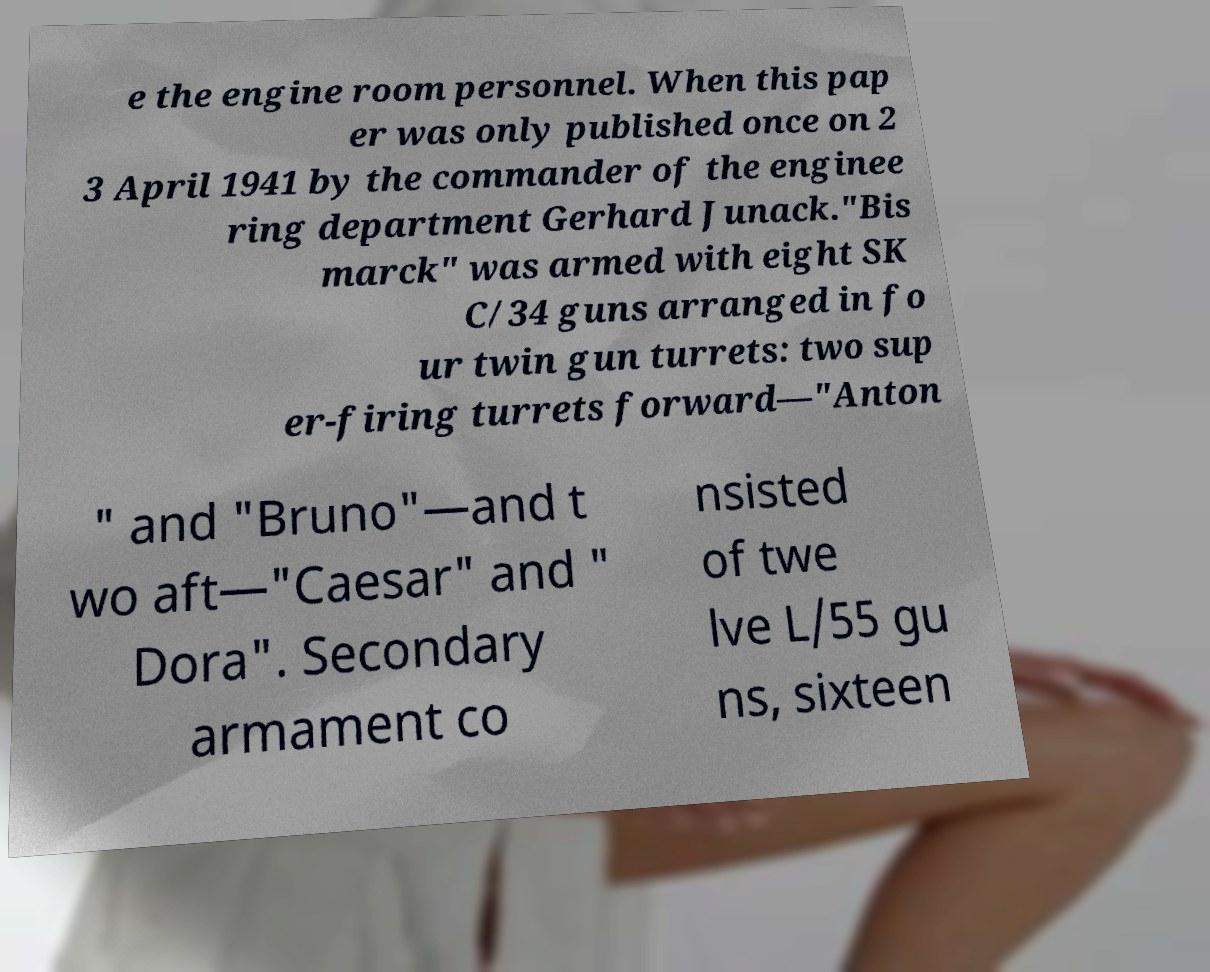What messages or text are displayed in this image? I need them in a readable, typed format. e the engine room personnel. When this pap er was only published once on 2 3 April 1941 by the commander of the enginee ring department Gerhard Junack."Bis marck" was armed with eight SK C/34 guns arranged in fo ur twin gun turrets: two sup er-firing turrets forward—"Anton " and "Bruno"—and t wo aft—"Caesar" and " Dora". Secondary armament co nsisted of twe lve L/55 gu ns, sixteen 